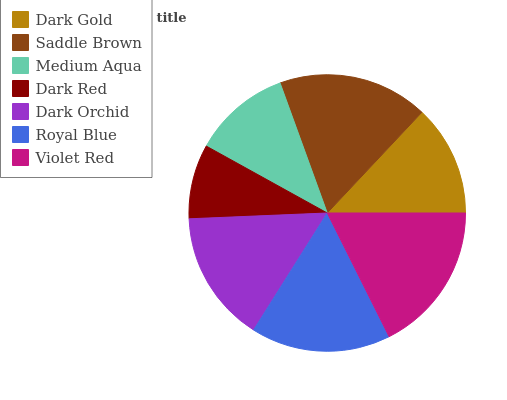Is Dark Red the minimum?
Answer yes or no. Yes. Is Violet Red the maximum?
Answer yes or no. Yes. Is Saddle Brown the minimum?
Answer yes or no. No. Is Saddle Brown the maximum?
Answer yes or no. No. Is Saddle Brown greater than Dark Gold?
Answer yes or no. Yes. Is Dark Gold less than Saddle Brown?
Answer yes or no. Yes. Is Dark Gold greater than Saddle Brown?
Answer yes or no. No. Is Saddle Brown less than Dark Gold?
Answer yes or no. No. Is Dark Orchid the high median?
Answer yes or no. Yes. Is Dark Orchid the low median?
Answer yes or no. Yes. Is Saddle Brown the high median?
Answer yes or no. No. Is Violet Red the low median?
Answer yes or no. No. 